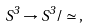Convert formula to latex. <formula><loc_0><loc_0><loc_500><loc_500>S ^ { 3 } \to S ^ { 3 } / \simeq \, ,</formula> 